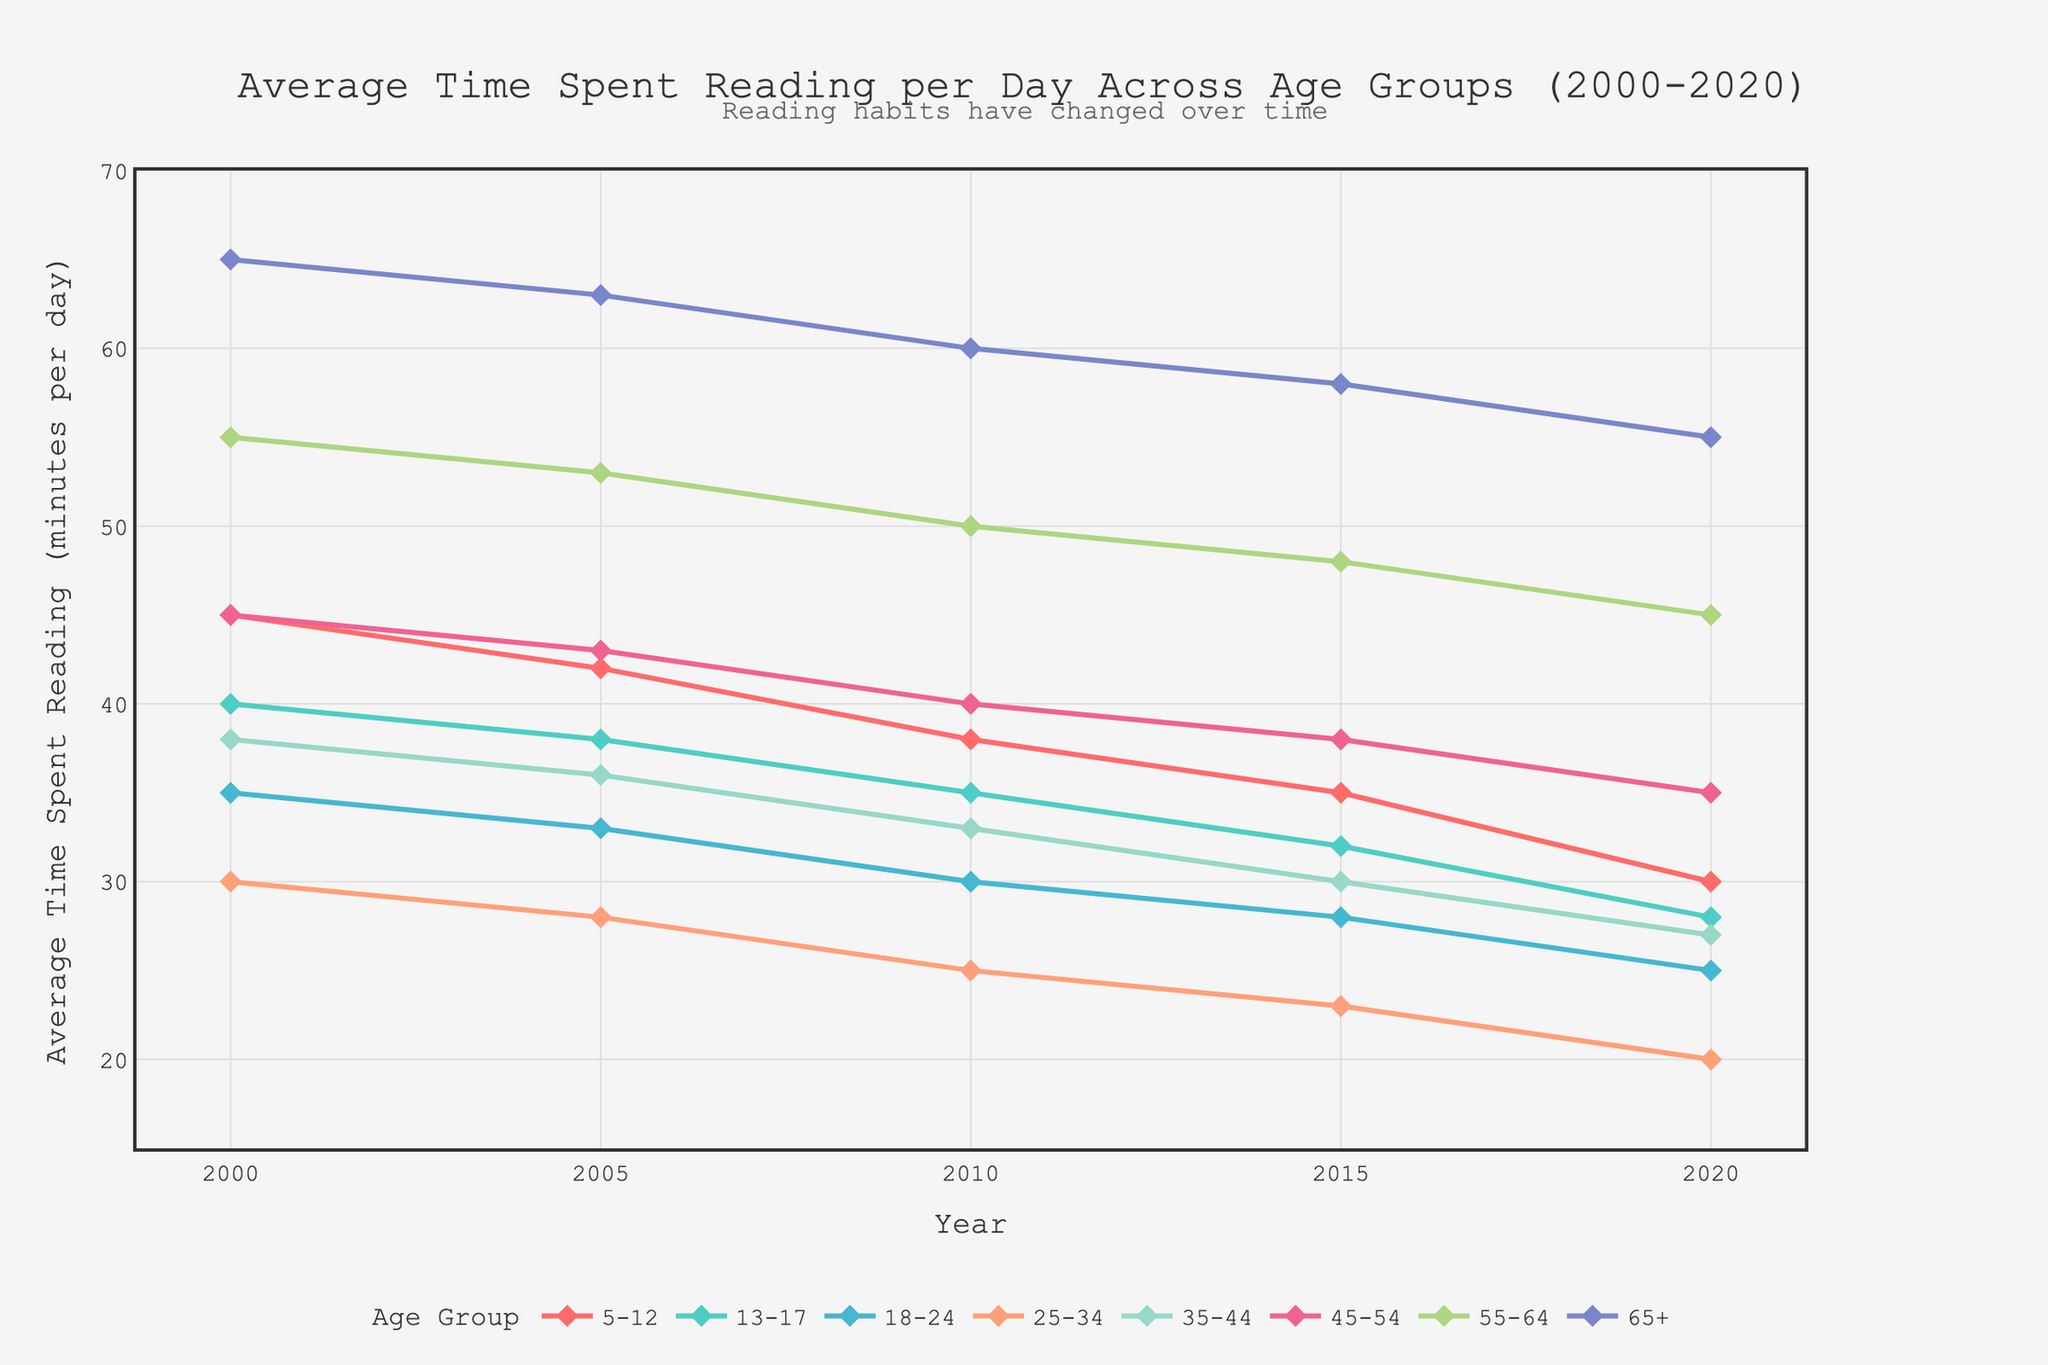What is the overall trend in the average time spent reading per day for all age groups over the 20-year span? Over the 20-year span from 2000 to 2020, the average time spent reading per day has a consistent downward trend across all age groups. This is evident as the lines for all age groups decline from left to right on the graph.
Answer: Downward trend Which age group spends the most time reading in 2020? By looking at the end of the chart for the year 2020, the top-most line corresponds to the 65+ age group, indicating they spend the most time reading.
Answer: 65+ Compare time spent reading between the 18-24 and 45-54 age groups in 2010. The chart shows the line for the 45-54 age group at 40 minutes and the line for the 18-24 age group at 30 minutes in 2010, indicating that 45-54 age group spent more time reading.
Answer: 45-54 age group How much has the average reading time decreased for the 35-44 age group from 2000 to 2020? For the 35-44 age group, the reading time decreased from 38 minutes in 2000 to 27 minutes in 2020. Subtracting these values gives a decrease of 11 minutes.
Answer: 11 minutes Compare the reading time of the 13-17 age group to the 25-34 age group in 2005. The chart shows that in 2005, the 13-17 age group spends 38 minutes reading per day while the 25-34 age group spends 28 minutes. Therefore, the 13-17 age group spends more time reading than the 25-34 age group in 2005.
Answer: 13-17 Which two age groups have the smallest difference in time spent reading in 2020? Looking at the year 2020, the 25-34 age group's line is at 20 minutes and the 35-44 age group's line is at 27 minutes. The difference between these times is 7 minutes, which is the smallest difference shown on the chart.
Answer: 25-34 and 35-44 What are the average numbers of minutes spent reading per day for the 5-12 and 65+ age groups over the last 20 years? For the 5-12 age group: (45 + 42 + 38 + 35 + 30)/5 = 38 minutes on average. For the 65+ age group: (65 + 63 + 60 + 58 + 55)/5 = 60.2 minutes on average.
Answer: 38 and 60.2 minutes Which age group shows the steepest decline in reading time between any two consecutive years? The steepest decline is for the 13-17 age group between 2015 and 2020, where the reading time dropped from 32 minutes to 28 minutes, making a decline of 4 minutes. No other age group shows a steeper decline in any two consecutive years.
Answer: 13-17 What is the total time spent reading per day by the 55-64 age group over the decades 2000s (2000-2009), 2010s (2010-2019), and 2020s (2020)? For 2000s: (55+53)/2 = 54 minutes (average), For 2010s: (50+48)/2 = 49 minutes (average), For 2020s: 45 minutes
So, the total is 54 + 49 + 45 = 148 minutes
Answer: 148 minutes In which year did the reading time for the 45-54 age group intersect the reading time for the 18-24 age group? Observing the chart, the lines for 45-54 and 18-24 age groups intersect around the year 2015, showing the same value.
Answer: 2015 